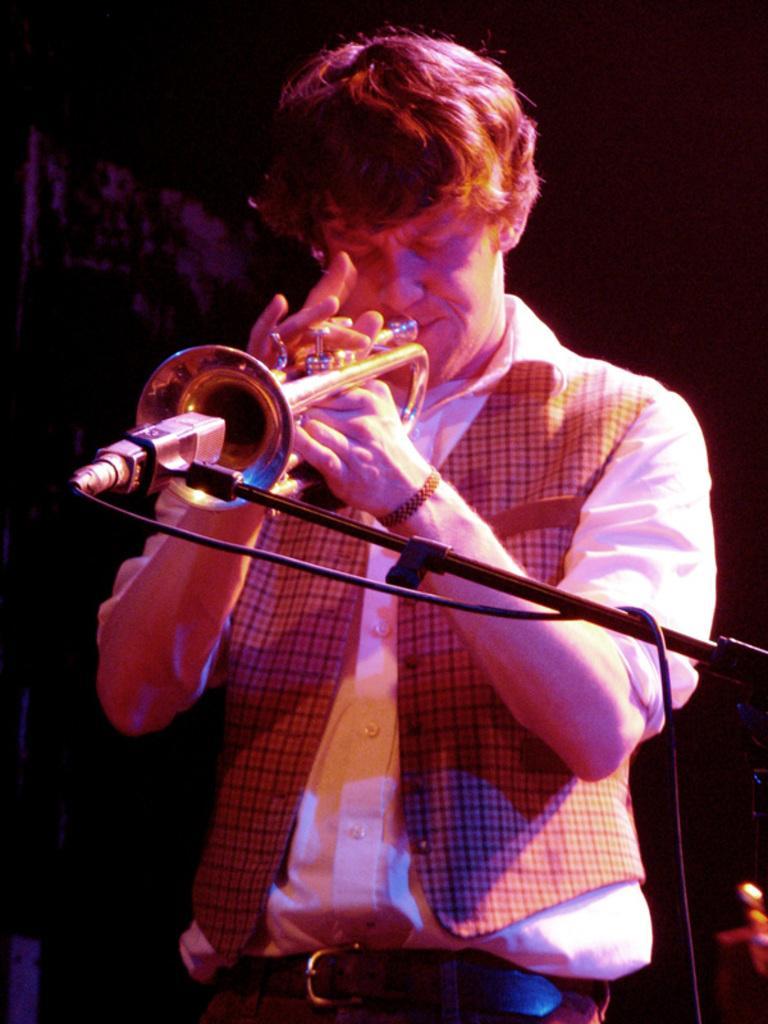In one or two sentences, can you explain what this image depicts? In this image we can see a man standing and playing a musical instrument, before him there is a mic placed on the stand. 